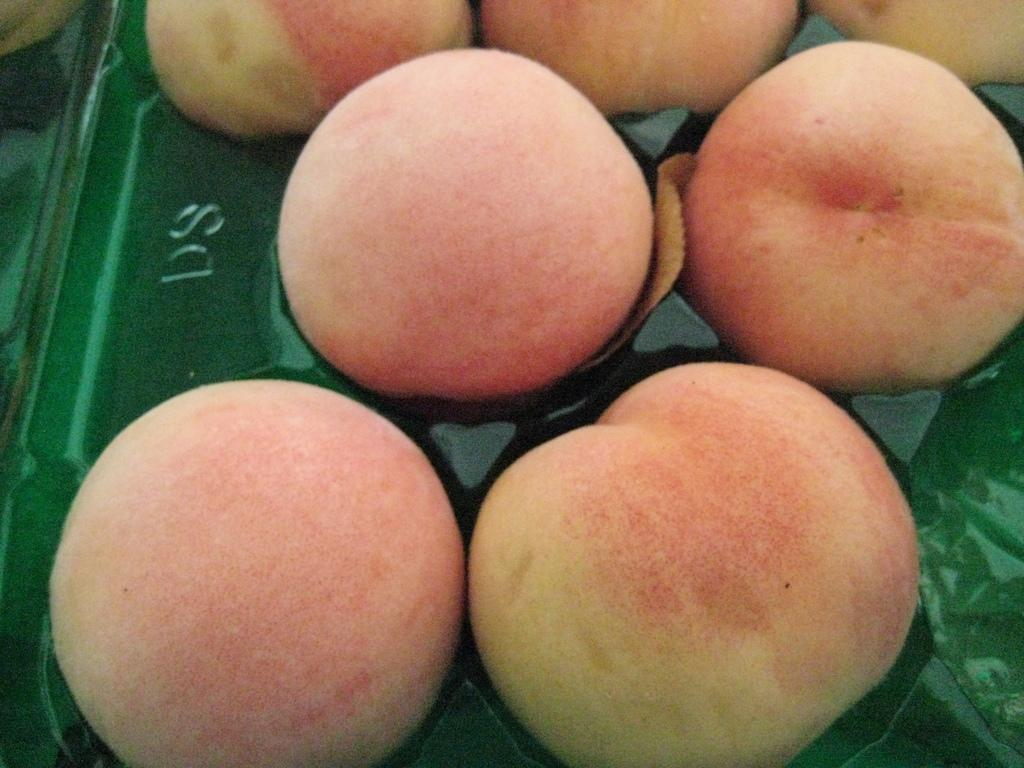What type of food can be seen in the image? There are fruits in the image. Can you describe the fruits in the image? Unfortunately, the facts provided do not give specific details about the fruits. How many fruits are visible in the image? The number of fruits in the image cannot be determined from the given facts. What type of jellyfish can be seen swimming in the image? There are no jellyfish present in the image; it features fruits. How many yolks are visible in the image? There are no yolks present in the image; it features fruits. 